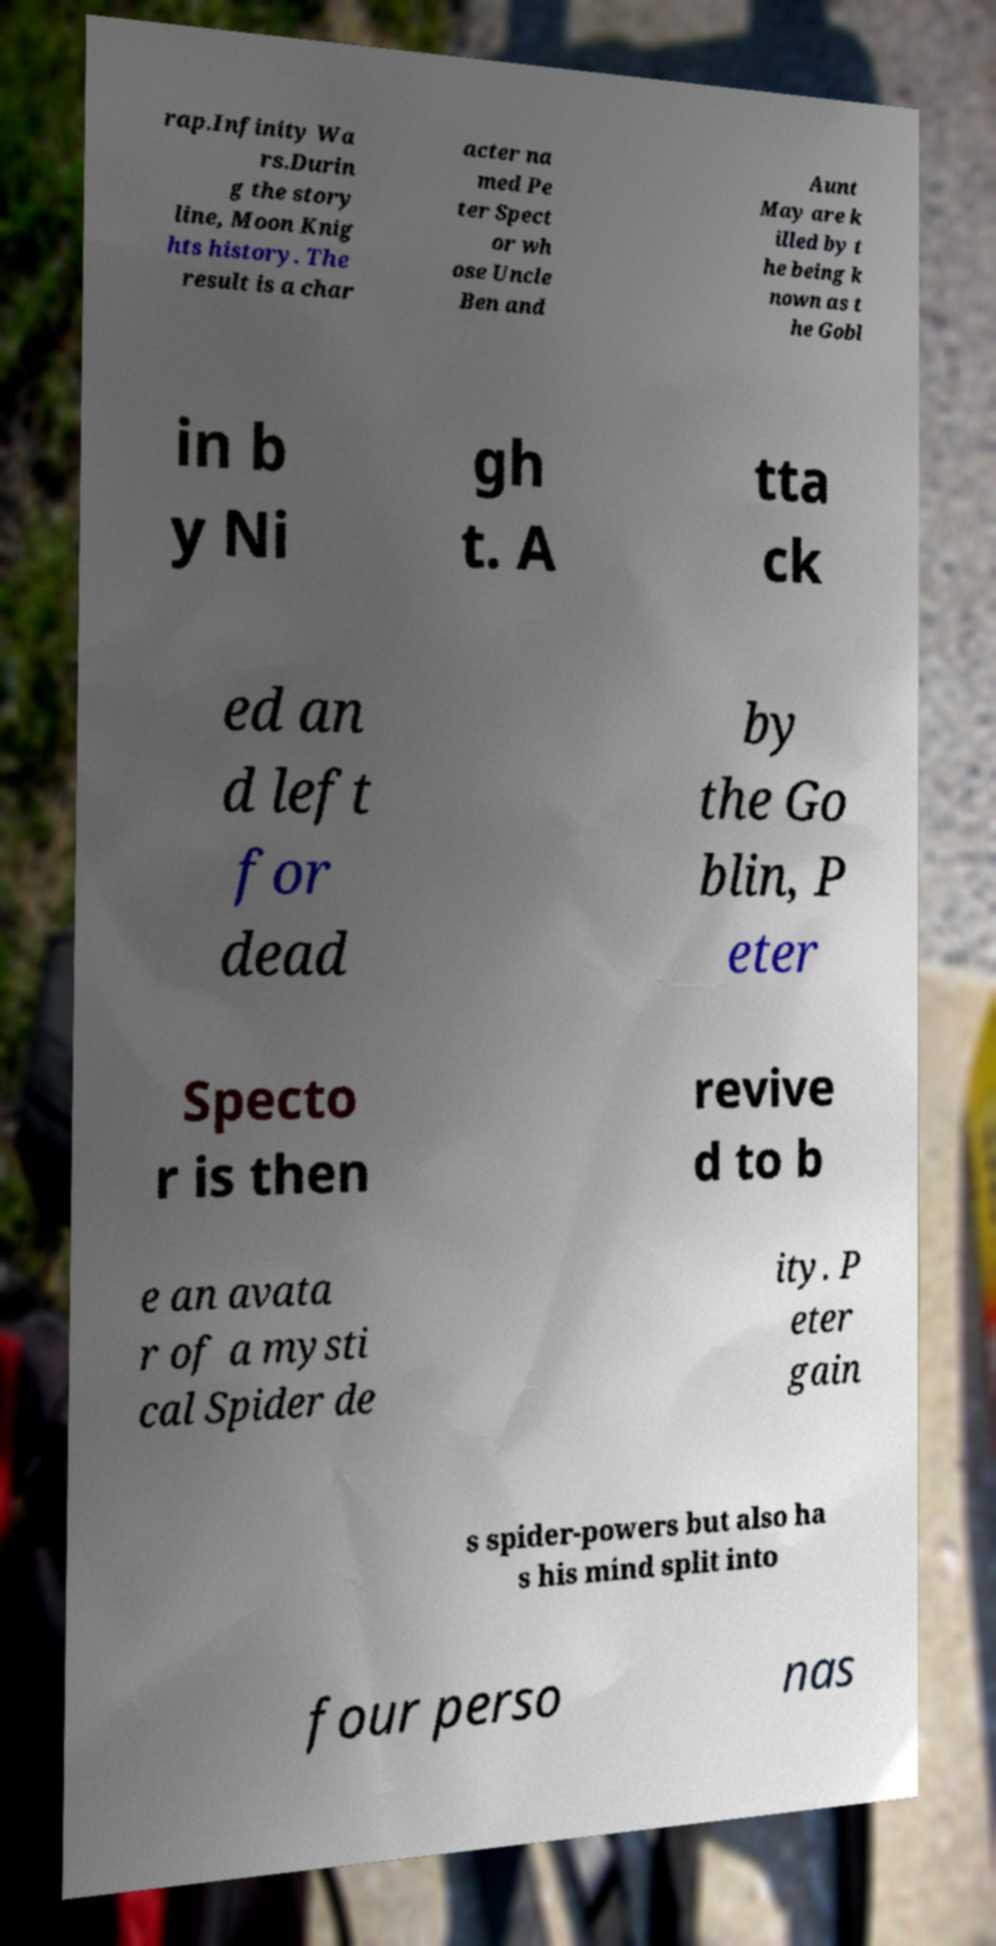Please identify and transcribe the text found in this image. rap.Infinity Wa rs.Durin g the story line, Moon Knig hts history. The result is a char acter na med Pe ter Spect or wh ose Uncle Ben and Aunt May are k illed by t he being k nown as t he Gobl in b y Ni gh t. A tta ck ed an d left for dead by the Go blin, P eter Specto r is then revive d to b e an avata r of a mysti cal Spider de ity. P eter gain s spider-powers but also ha s his mind split into four perso nas 